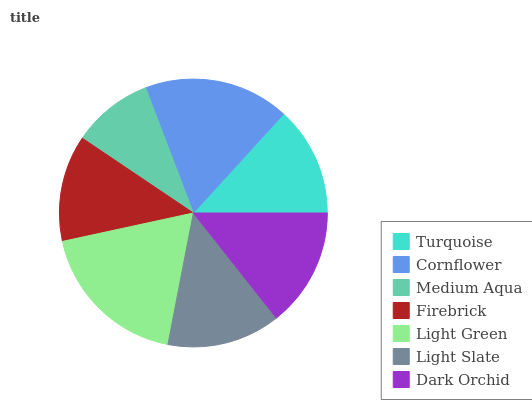Is Medium Aqua the minimum?
Answer yes or no. Yes. Is Light Green the maximum?
Answer yes or no. Yes. Is Cornflower the minimum?
Answer yes or no. No. Is Cornflower the maximum?
Answer yes or no. No. Is Cornflower greater than Turquoise?
Answer yes or no. Yes. Is Turquoise less than Cornflower?
Answer yes or no. Yes. Is Turquoise greater than Cornflower?
Answer yes or no. No. Is Cornflower less than Turquoise?
Answer yes or no. No. Is Light Slate the high median?
Answer yes or no. Yes. Is Light Slate the low median?
Answer yes or no. Yes. Is Turquoise the high median?
Answer yes or no. No. Is Dark Orchid the low median?
Answer yes or no. No. 